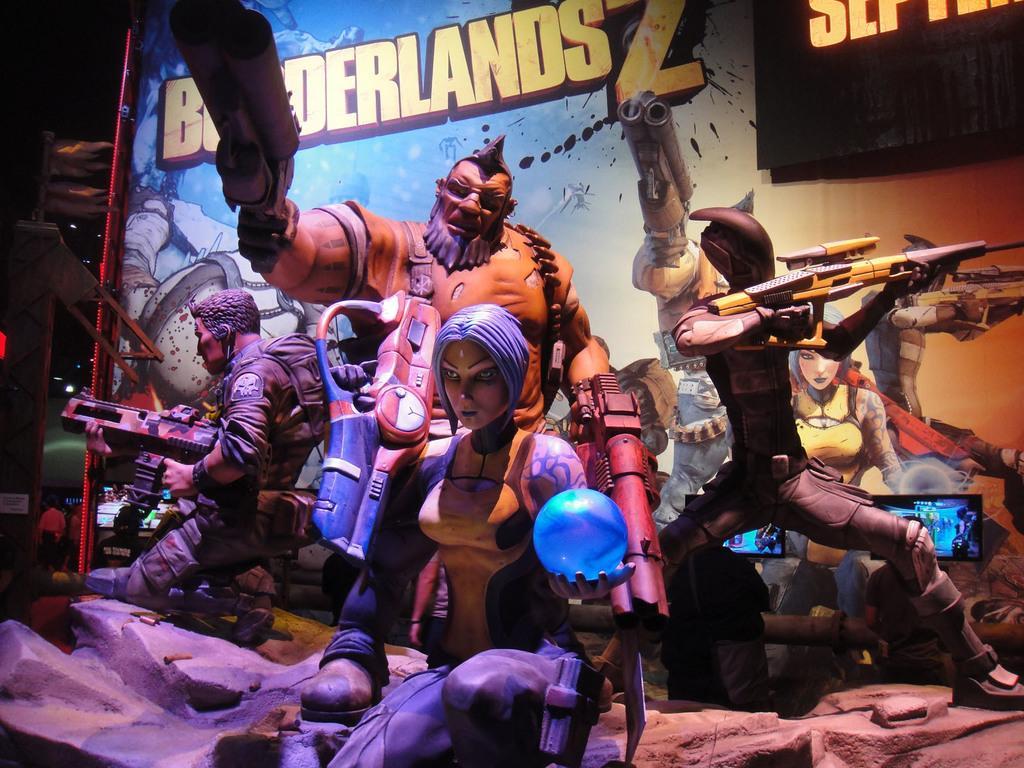Could you give a brief overview of what you see in this image? In this image we can see the depictions of men and also women holding the objects. In the background, we can see the painting and also the text on the wall. In the top right corner there is screen and at the bottom we can see the rock. 